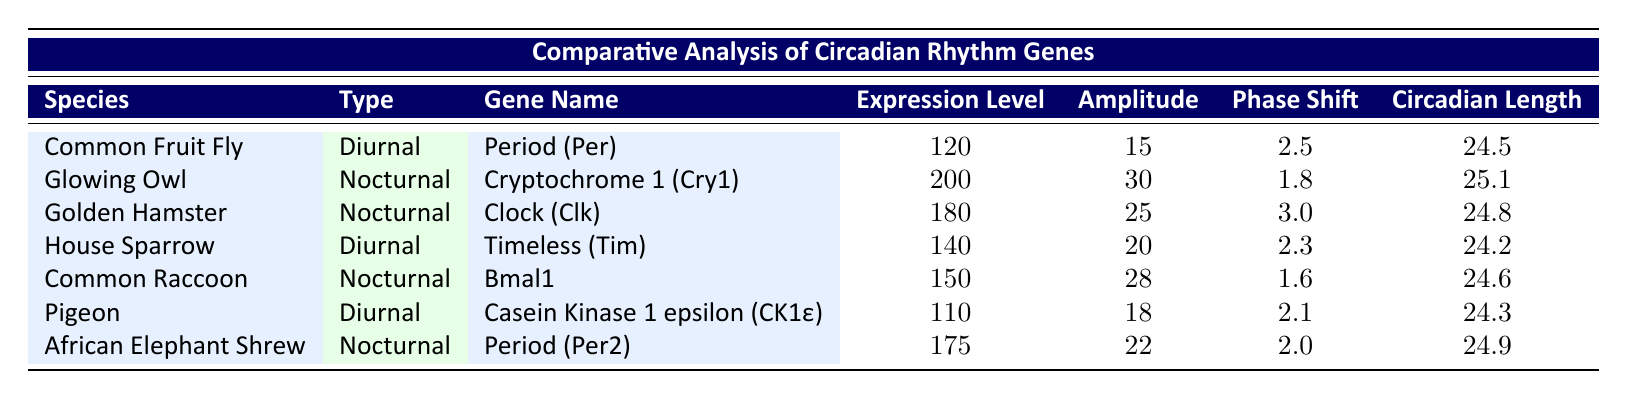What is the expression level of the Glowing Owl? The expression level for the Glowing Owl is listed directly in the table under the "Expression Level" column. According to the table, the value is 200.
Answer: 200 Which nocturnal species has the highest amplitude in circadian rhythm gene expression? To find the species with the highest amplitude among nocturnal species, we compare the amplitudes: Glowing Owl (30), Golden Hamster (25), Common Raccoon (28), and African Elephant Shrew (22). The highest value is 30, which belongs to the Glowing Owl.
Answer: Glowing Owl Is the circadian length of the Golden Hamster shorter than that of the House Sparrow? The circadian length of the Golden Hamster is 24.8, while that of the House Sparrow is 24.2. Since 24.8 is greater than 24.2, the statement is false.
Answer: No What is the average expression level for diurnal species? The diurnal species are Common Fruit Fly (120), House Sparrow (140), and Pigeon (110). To find the average, we sum these values: 120 + 140 + 110 = 370, and divide by 3 (the number of diurnal species): 370 / 3 = 123.33.
Answer: 123.33 Which gene has the largest phase shift value among the nocturnal species? We examine the phase shifts for the nocturnal species: Glowing Owl (1.8), Golden Hamster (3.0), Common Raccoon (1.6), and African Elephant Shrew (2.0). The largest value is 3.0 from the Golden Hamster.
Answer: Golden Hamster 